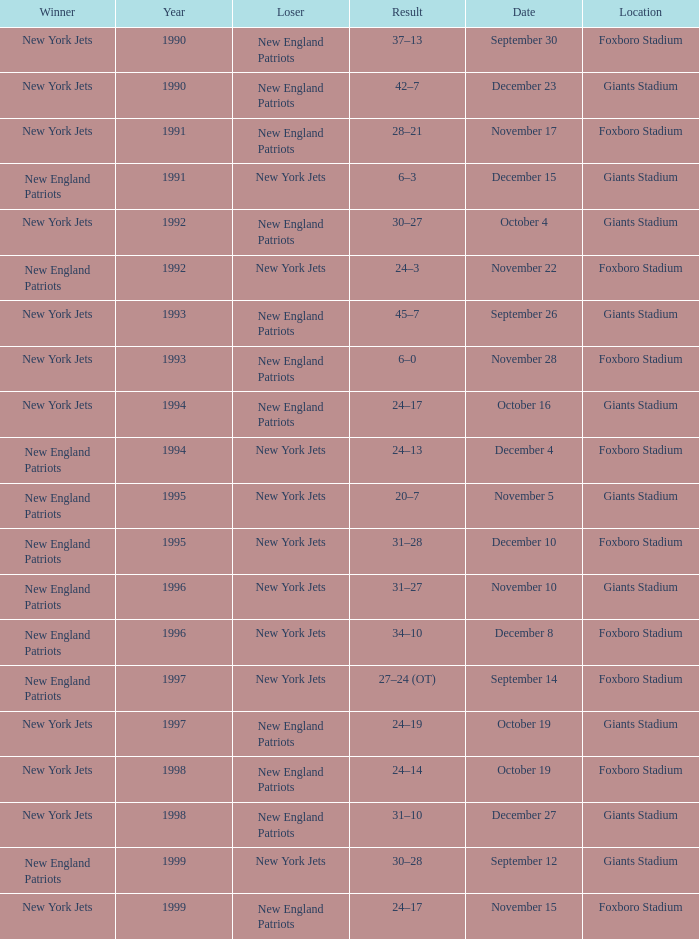What team was the lower when the winner was the new york jets, and a Year earlier than 1994, and a Result of 37–13? New England Patriots. 